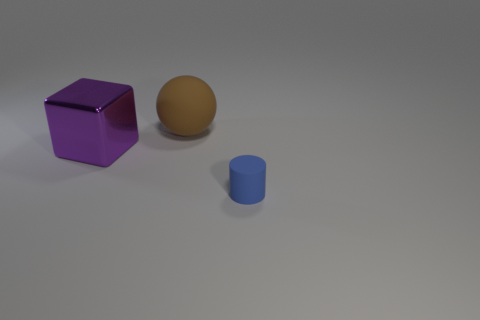Subtract all cylinders. How many objects are left? 2 Subtract 1 blocks. How many blocks are left? 0 Add 2 brown balls. How many brown balls are left? 3 Add 2 green rubber spheres. How many green rubber spheres exist? 2 Add 1 metallic cubes. How many objects exist? 4 Subtract 0 cyan balls. How many objects are left? 3 Subtract all yellow cylinders. Subtract all blue spheres. How many cylinders are left? 1 Subtract all small red rubber things. Subtract all matte cylinders. How many objects are left? 2 